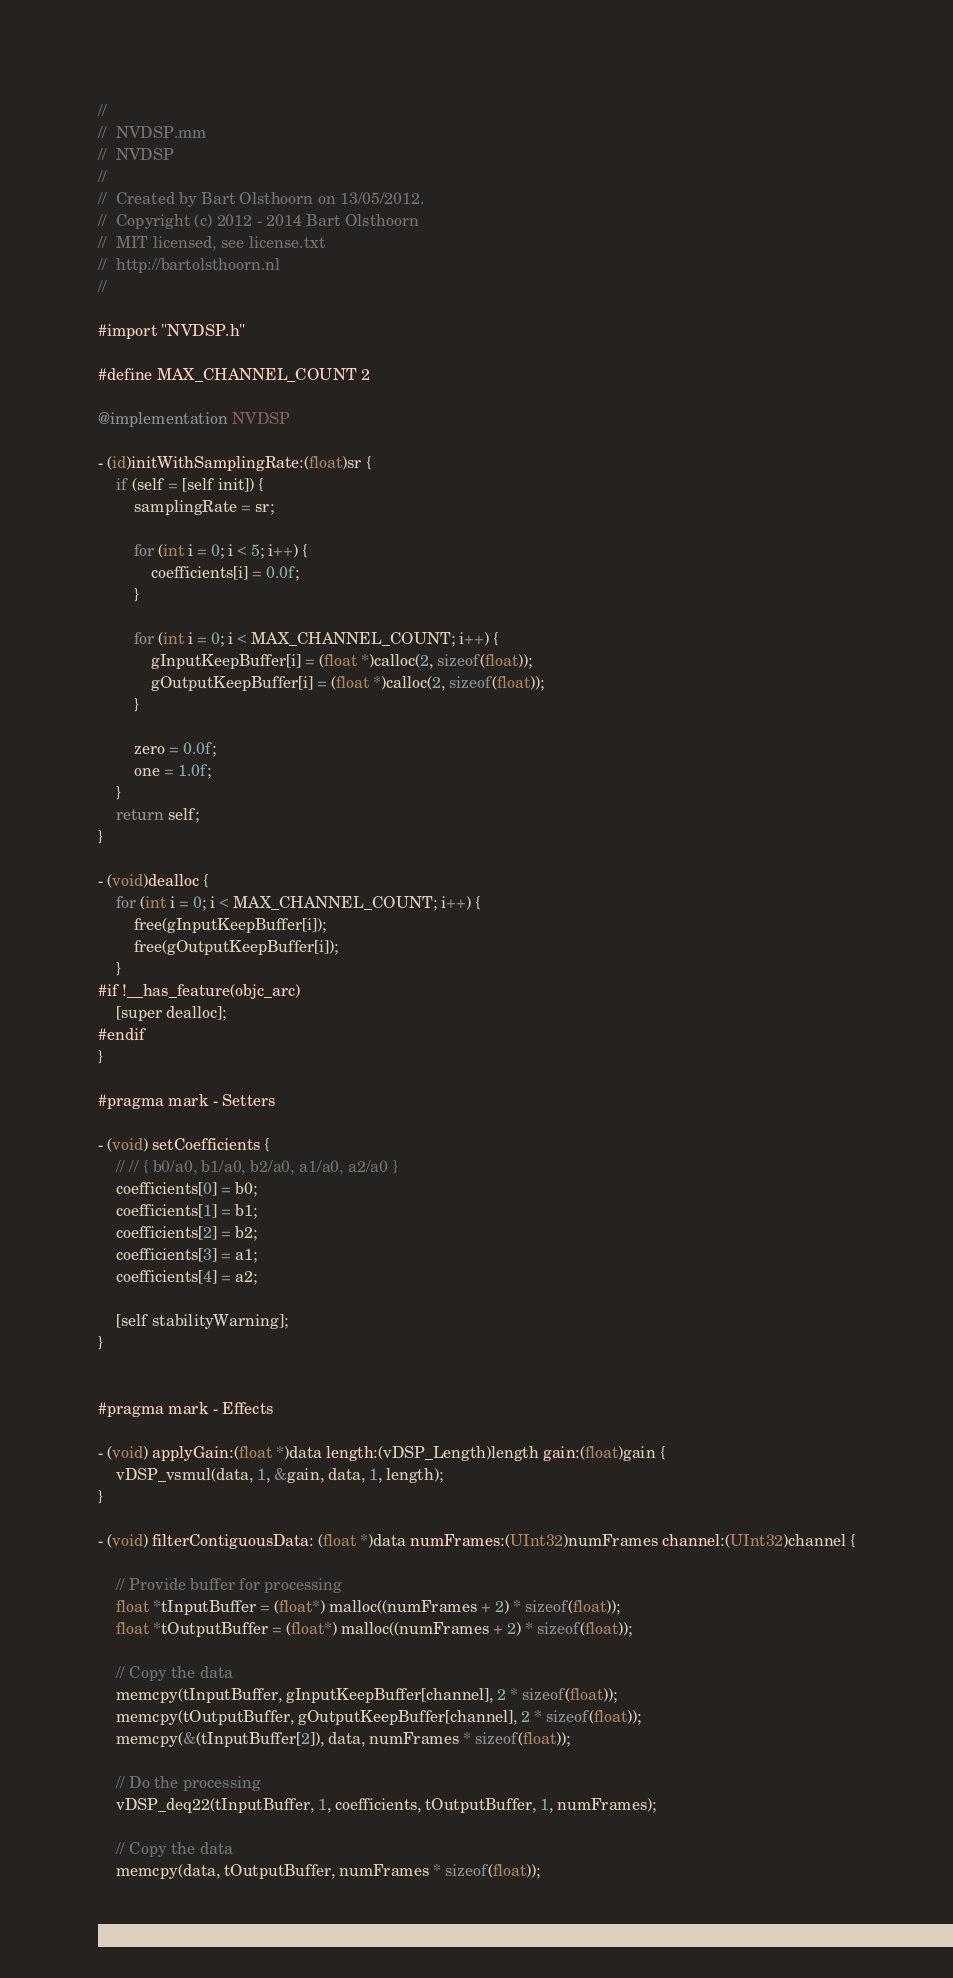Convert code to text. <code><loc_0><loc_0><loc_500><loc_500><_ObjectiveC_>//
//  NVDSP.mm
//  NVDSP
//
//  Created by Bart Olsthoorn on 13/05/2012.
//  Copyright (c) 2012 - 2014 Bart Olsthoorn
//  MIT licensed, see license.txt
//  http://bartolsthoorn.nl
//

#import "NVDSP.h"

#define MAX_CHANNEL_COUNT 2

@implementation NVDSP

- (id)initWithSamplingRate:(float)sr {
    if (self = [self init]) {
        samplingRate = sr;

        for (int i = 0; i < 5; i++) {
            coefficients[i] = 0.0f;
        }

        for (int i = 0; i < MAX_CHANNEL_COUNT; i++) {
            gInputKeepBuffer[i] = (float *)calloc(2, sizeof(float));
            gOutputKeepBuffer[i] = (float *)calloc(2, sizeof(float));
        }

        zero = 0.0f;
        one = 1.0f;
    }
    return self;
}

- (void)dealloc {
    for (int i = 0; i < MAX_CHANNEL_COUNT; i++) {
        free(gInputKeepBuffer[i]);
        free(gOutputKeepBuffer[i]);
    }
#if !__has_feature(objc_arc)
    [super dealloc];
#endif
}

#pragma mark - Setters

- (void) setCoefficients {
    // // { b0/a0, b1/a0, b2/a0, a1/a0, a2/a0 }
    coefficients[0] = b0;
    coefficients[1] = b1;
    coefficients[2] = b2;
    coefficients[3] = a1;
    coefficients[4] = a2;
    
    [self stabilityWarning];
}


#pragma mark - Effects

- (void) applyGain:(float *)data length:(vDSP_Length)length gain:(float)gain {
    vDSP_vsmul(data, 1, &gain, data, 1, length);
}

- (void) filterContiguousData: (float *)data numFrames:(UInt32)numFrames channel:(UInt32)channel {
    
    // Provide buffer for processing
    float *tInputBuffer = (float*) malloc((numFrames + 2) * sizeof(float));
    float *tOutputBuffer = (float*) malloc((numFrames + 2) * sizeof(float));
    
    // Copy the data
    memcpy(tInputBuffer, gInputKeepBuffer[channel], 2 * sizeof(float));
    memcpy(tOutputBuffer, gOutputKeepBuffer[channel], 2 * sizeof(float));
    memcpy(&(tInputBuffer[2]), data, numFrames * sizeof(float));
    
    // Do the processing
    vDSP_deq22(tInputBuffer, 1, coefficients, tOutputBuffer, 1, numFrames);
    
    // Copy the data
    memcpy(data, tOutputBuffer, numFrames * sizeof(float));</code> 